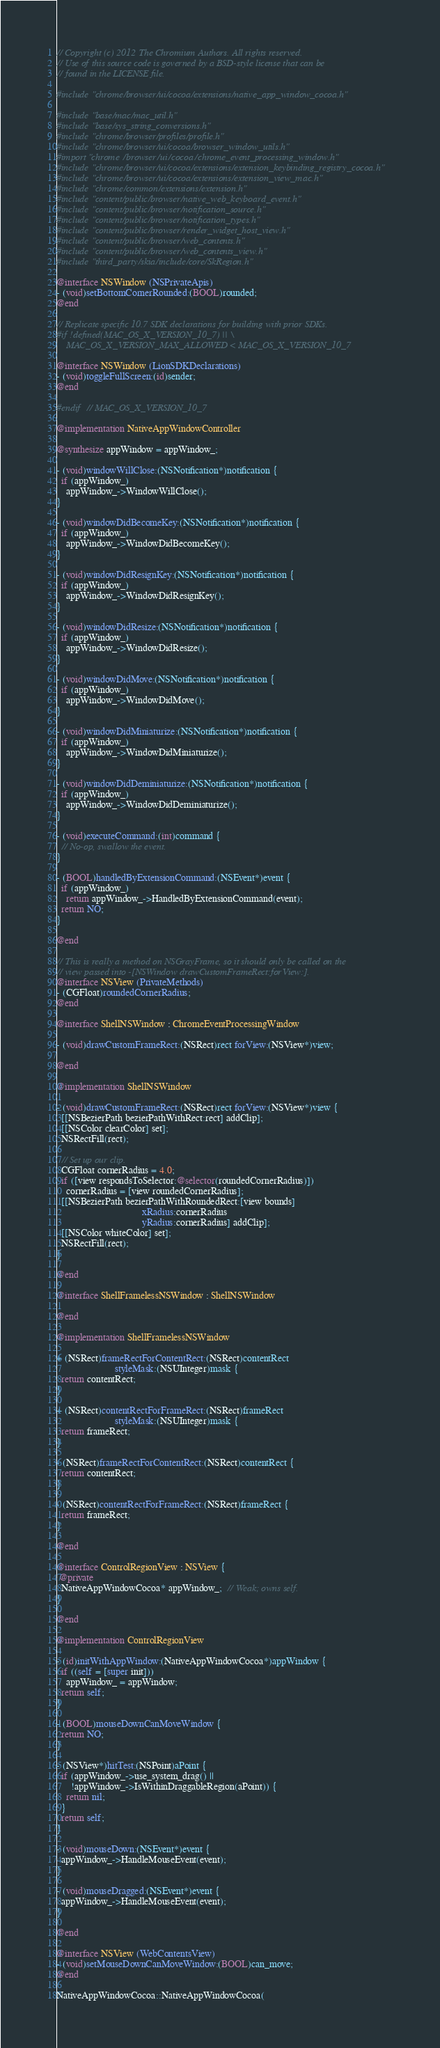Convert code to text. <code><loc_0><loc_0><loc_500><loc_500><_ObjectiveC_>// Copyright (c) 2012 The Chromium Authors. All rights reserved.
// Use of this source code is governed by a BSD-style license that can be
// found in the LICENSE file.

#include "chrome/browser/ui/cocoa/extensions/native_app_window_cocoa.h"

#include "base/mac/mac_util.h"
#include "base/sys_string_conversions.h"
#include "chrome/browser/profiles/profile.h"
#include "chrome/browser/ui/cocoa/browser_window_utils.h"
#import "chrome/browser/ui/cocoa/chrome_event_processing_window.h"
#include "chrome/browser/ui/cocoa/extensions/extension_keybinding_registry_cocoa.h"
#include "chrome/browser/ui/cocoa/extensions/extension_view_mac.h"
#include "chrome/common/extensions/extension.h"
#include "content/public/browser/native_web_keyboard_event.h"
#include "content/public/browser/notification_source.h"
#include "content/public/browser/notification_types.h"
#include "content/public/browser/render_widget_host_view.h"
#include "content/public/browser/web_contents.h"
#include "content/public/browser/web_contents_view.h"
#include "third_party/skia/include/core/SkRegion.h"

@interface NSWindow (NSPrivateApis)
- (void)setBottomCornerRounded:(BOOL)rounded;
@end

// Replicate specific 10.7 SDK declarations for building with prior SDKs.
#if !defined(MAC_OS_X_VERSION_10_7) || \
    MAC_OS_X_VERSION_MAX_ALLOWED < MAC_OS_X_VERSION_10_7

@interface NSWindow (LionSDKDeclarations)
- (void)toggleFullScreen:(id)sender;
@end

#endif  // MAC_OS_X_VERSION_10_7

@implementation NativeAppWindowController

@synthesize appWindow = appWindow_;

- (void)windowWillClose:(NSNotification*)notification {
  if (appWindow_)
    appWindow_->WindowWillClose();
}

- (void)windowDidBecomeKey:(NSNotification*)notification {
  if (appWindow_)
    appWindow_->WindowDidBecomeKey();
}

- (void)windowDidResignKey:(NSNotification*)notification {
  if (appWindow_)
    appWindow_->WindowDidResignKey();
}

- (void)windowDidResize:(NSNotification*)notification {
  if (appWindow_)
    appWindow_->WindowDidResize();
}

- (void)windowDidMove:(NSNotification*)notification {
  if (appWindow_)
    appWindow_->WindowDidMove();
}

- (void)windowDidMiniaturize:(NSNotification*)notification {
  if (appWindow_)
    appWindow_->WindowDidMiniaturize();
}

- (void)windowDidDeminiaturize:(NSNotification*)notification {
  if (appWindow_)
    appWindow_->WindowDidDeminiaturize();
}

- (void)executeCommand:(int)command {
  // No-op, swallow the event.
}

- (BOOL)handledByExtensionCommand:(NSEvent*)event {
  if (appWindow_)
    return appWindow_->HandledByExtensionCommand(event);
  return NO;
}

@end

// This is really a method on NSGrayFrame, so it should only be called on the
// view passed into -[NSWindow drawCustomFrameRect:forView:].
@interface NSView (PrivateMethods)
- (CGFloat)roundedCornerRadius;
@end

@interface ShellNSWindow : ChromeEventProcessingWindow

- (void)drawCustomFrameRect:(NSRect)rect forView:(NSView*)view;

@end

@implementation ShellNSWindow

- (void)drawCustomFrameRect:(NSRect)rect forView:(NSView*)view {
  [[NSBezierPath bezierPathWithRect:rect] addClip];
  [[NSColor clearColor] set];
  NSRectFill(rect);

  // Set up our clip.
  CGFloat cornerRadius = 4.0;
  if ([view respondsToSelector:@selector(roundedCornerRadius)])
    cornerRadius = [view roundedCornerRadius];
  [[NSBezierPath bezierPathWithRoundedRect:[view bounds]
                                   xRadius:cornerRadius
                                   yRadius:cornerRadius] addClip];
  [[NSColor whiteColor] set];
  NSRectFill(rect);
}

@end

@interface ShellFramelessNSWindow : ShellNSWindow

@end

@implementation ShellFramelessNSWindow

+ (NSRect)frameRectForContentRect:(NSRect)contentRect
                        styleMask:(NSUInteger)mask {
  return contentRect;
}

+ (NSRect)contentRectForFrameRect:(NSRect)frameRect
                        styleMask:(NSUInteger)mask {
  return frameRect;
}

- (NSRect)frameRectForContentRect:(NSRect)contentRect {
  return contentRect;
}

- (NSRect)contentRectForFrameRect:(NSRect)frameRect {
  return frameRect;
}

@end

@interface ControlRegionView : NSView {
 @private
  NativeAppWindowCocoa* appWindow_;  // Weak; owns self.
}

@end

@implementation ControlRegionView

- (id)initWithAppWindow:(NativeAppWindowCocoa*)appWindow {
  if ((self = [super init]))
    appWindow_ = appWindow;
  return self;
}

- (BOOL)mouseDownCanMoveWindow {
  return NO;
}

- (NSView*)hitTest:(NSPoint)aPoint {
  if (appWindow_->use_system_drag() ||
      !appWindow_->IsWithinDraggableRegion(aPoint)) {
    return nil;
  }
  return self;
}

- (void)mouseDown:(NSEvent*)event {
  appWindow_->HandleMouseEvent(event);
}

- (void)mouseDragged:(NSEvent*)event {
  appWindow_->HandleMouseEvent(event);
}

@end

@interface NSView (WebContentsView)
- (void)setMouseDownCanMoveWindow:(BOOL)can_move;
@end

NativeAppWindowCocoa::NativeAppWindowCocoa(</code> 